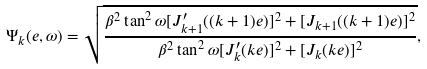Convert formula to latex. <formula><loc_0><loc_0><loc_500><loc_500>\Psi _ { k } ( e , \omega ) = \sqrt { \frac { \beta ^ { 2 } \tan ^ { 2 } \omega [ J _ { k + 1 } ^ { \prime } ( ( k + 1 ) e ) ] ^ { 2 } + [ J _ { k + 1 } ( ( k + 1 ) e ) ] ^ { 2 } } { \beta ^ { 2 } \tan ^ { 2 } \omega [ J _ { k } ^ { \prime } ( k e ) ] ^ { 2 } + [ J _ { k } ( k e ) ] ^ { 2 } } } ,</formula> 